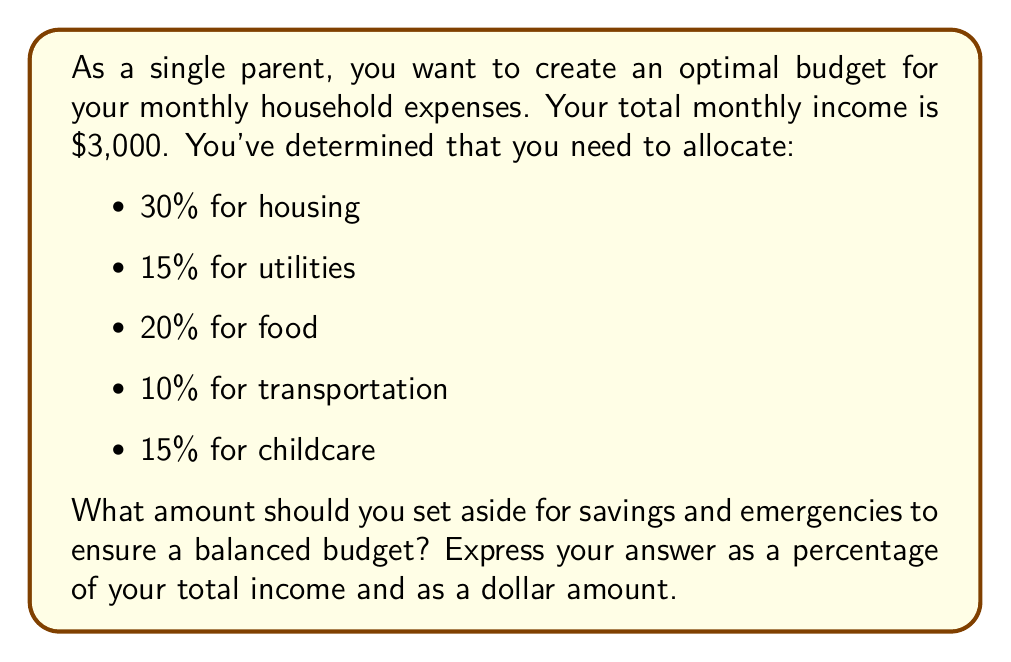Help me with this question. To solve this problem, we need to:
1. Calculate the total percentage allocated for known expenses
2. Subtract this percentage from 100% to find the remaining percentage for savings
3. Calculate the dollar amount based on the percentage and total income

Step 1: Calculate total percentage for known expenses
$$30\% + 15\% + 20\% + 10\% + 15\% = 90\%$$

Step 2: Calculate remaining percentage for savings
$$100\% - 90\% = 10\%$$

Step 3: Calculate dollar amount for savings
Let $x$ be the amount for savings:
$$x = 10\% \times \$3,000$$
$$x = 0.10 \times \$3,000 = \$300$$

Therefore, the optimal budget allocation for savings and emergencies is 10% of the total income, which amounts to $300.
Answer: 10% or $300 